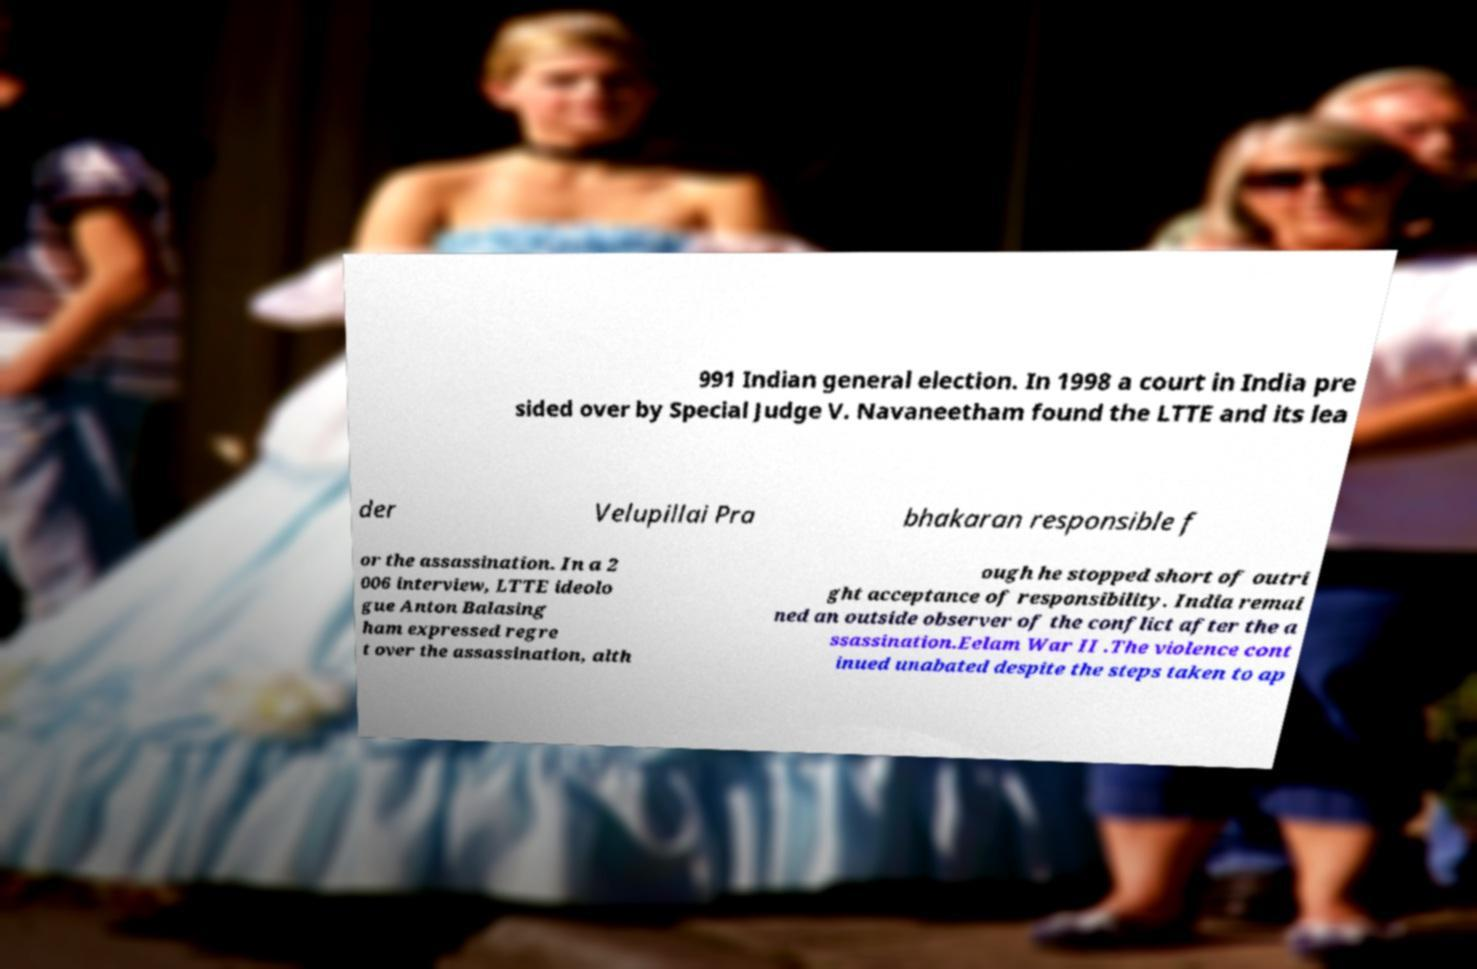Please identify and transcribe the text found in this image. 991 Indian general election. In 1998 a court in India pre sided over by Special Judge V. Navaneetham found the LTTE and its lea der Velupillai Pra bhakaran responsible f or the assassination. In a 2 006 interview, LTTE ideolo gue Anton Balasing ham expressed regre t over the assassination, alth ough he stopped short of outri ght acceptance of responsibility. India remai ned an outside observer of the conflict after the a ssassination.Eelam War II .The violence cont inued unabated despite the steps taken to ap 